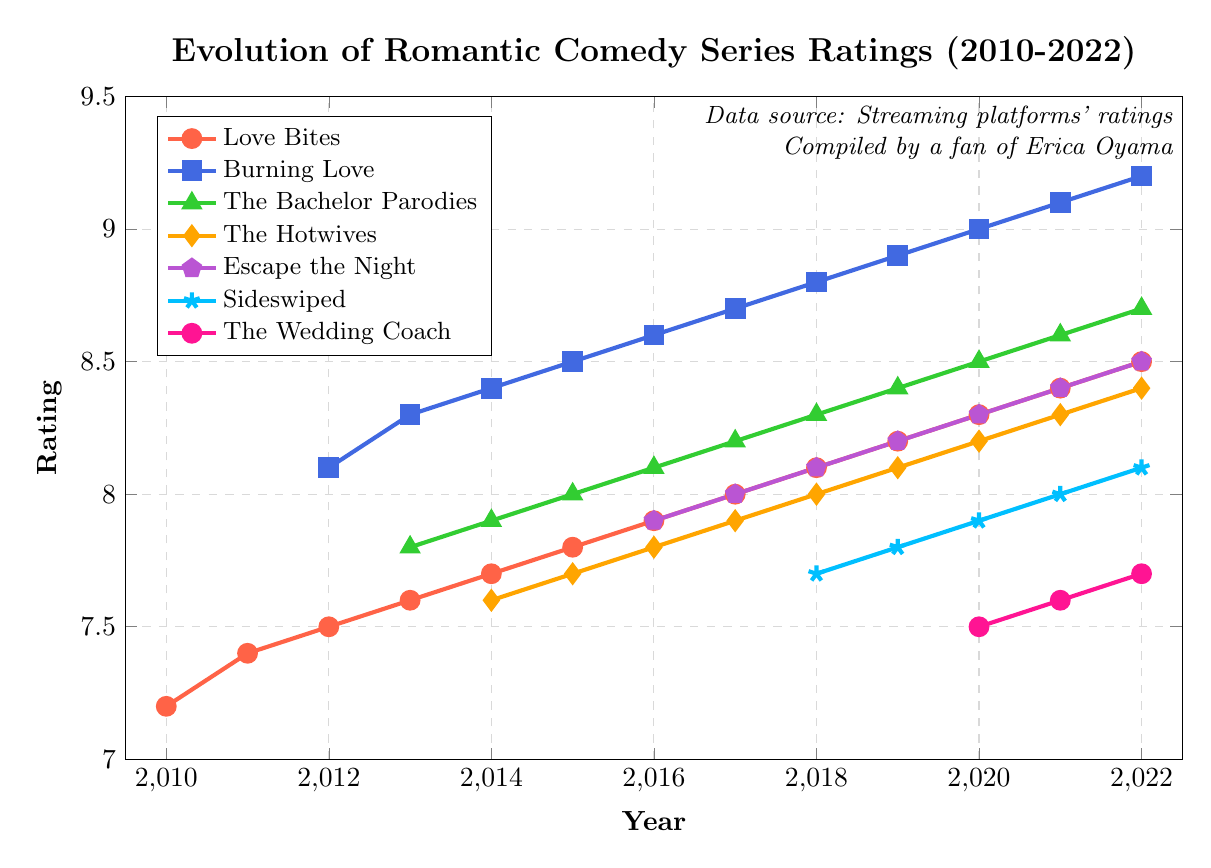What's the highest rating for "Burning Love"? Look for the highest point on the line representing "Burning Love". It reaches its peak at 9.2 in 2022.
Answer: 9.2 Which series had its rating increase every year from its start? Look for series lines that show consistent upward slopes without any dips or flat segments. "Burning Love", "The Bachelor Parodies", and "Escape the Night" show this trend.
Answer: Burning Love, The Bachelor Parodies, Escape the Night In which year did "Love Bites" achieve a rating of 8.0 or higher for the first time? Check the data points for "Love Bites" line to see when it first meets or surpasses 8.0. It happened in 2017.
Answer: 2017 Compare the rating trends of "Love Bites" and "Burning Love". Which one had a steeper average rate of increase? Calculate the slope for each series. For "Love Bites", it's (8.5 - 7.2)/(2022 - 2010) = 0.108 per year. For "Burning Love", it's (9.2 - 8.1)/(2022 - 2012) = 0.11 per year. "Burning Love" has a slightly steeper average rate.
Answer: Burning Love What's the median rating for "The Bachelor Parodies" over the years it is available? Collect the ratings of "The Bachelor Parodies": [7.8, 7.9, 8.0, 8.1, 8.2, 8.3, 8.4, 8.5, 8.6, 8.7]. The median is the average of the 5th and 6th values in the list (8.2 + 8.3)/2 = 8.25.
Answer: 8.25 Which series experienced the largest single-year rating increase? Look for the steepest upward segment in any series' line. "Burning Love" had an increase from 8.1 in 2012 to 8.3 in 2013.
Answer: Burning Love What is the average rating of "The Hotwives" from 2014 to 2022? Sum the ratings of "The Hotwives": (7.6 + 7.7 + 7.8 + 7.9 + 8.0 + 8.1 + 8.2 + 8.3 + 8.4) = 72. Then divide by the number of data points (9), so the average is 72 / 9 = 8.
Answer: 8 How many series had a rating above 8.0 in 2020? Count the number of series lines that cross the 8.0 mark in 2020. The series are "Love Bites", "Burning Love", "The Bachelor Parodies", "The Hotwives", and "Escape the Night".
Answer: 5 Which series had the lowest initial rating, and what was that rating? Identify the series starting with the lowest rating. "Love Bites" began with a rating of 7.2 in 2010.
Answer: Love Bites, 7.2 